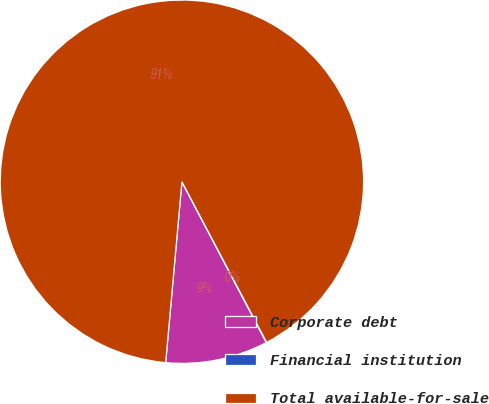Convert chart to OTSL. <chart><loc_0><loc_0><loc_500><loc_500><pie_chart><fcel>Corporate debt<fcel>Financial institution<fcel>Total available-for-sale<nl><fcel>9.12%<fcel>0.03%<fcel>90.85%<nl></chart> 